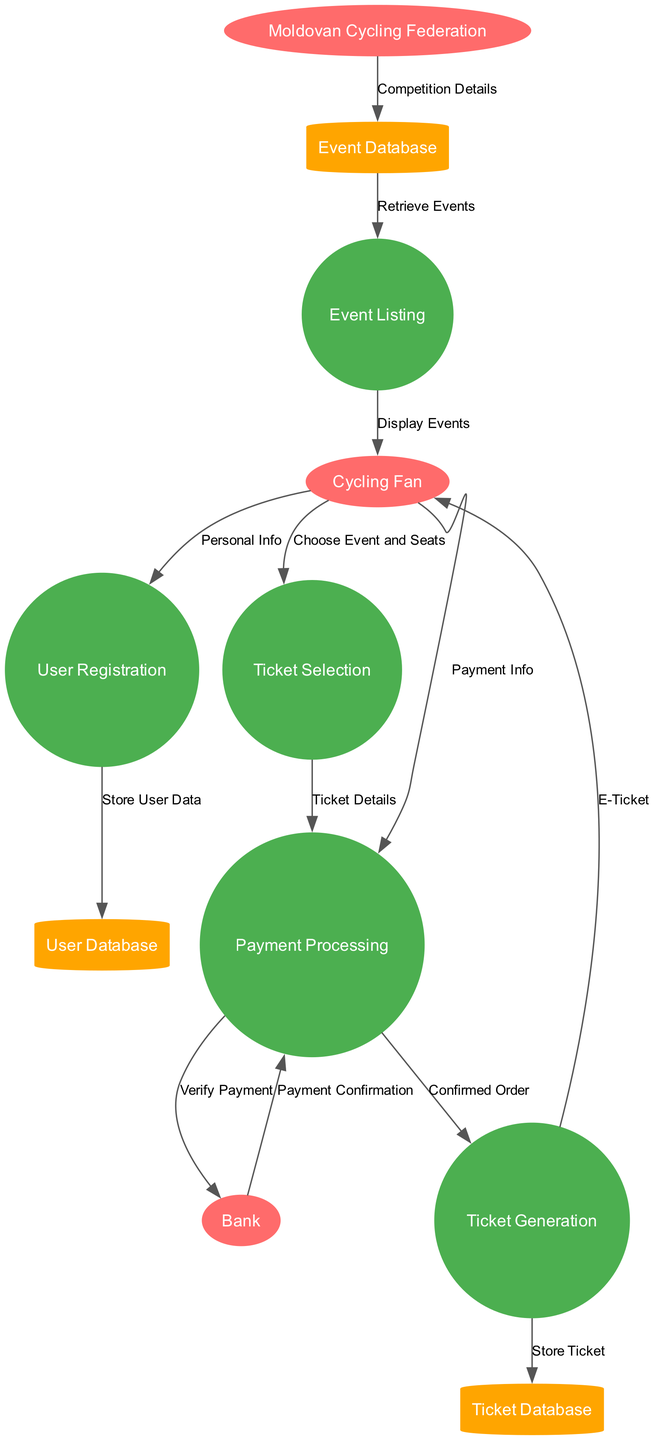What are the external entities in the diagram? The external entities listed are Cycling Fan, Bank, and Moldovan Cycling Federation. These entities represent outside participants that interact with the online ticket sales system.
Answer: Cycling Fan, Bank, Moldovan Cycling Federation How many processes are there in the diagram? The diagram contains five processes: User Registration, Event Listing, Ticket Selection, Payment Processing, and Ticket Generation. By counting these processes, we find the total number.
Answer: 5 Which process does the Ticket Selection connect to directly? The Ticket Selection process flows directly to the Payment Processing process. This is indicated by the data flow that shows how the selected ticket details are sent for further processing.
Answer: Payment Processing What information does the Cycling Fan send to the User Registration process? The Cycling Fan sends Personal Info to the User Registration process. This information is necessary for creating an account for the cycling fan in the system.
Answer: Personal Info What data store is updated when a new user registers? The User Database is updated when a new user registers. The data flow indicates that user data must be stored following the user registration process.
Answer: User Database Which entity is responsible for providing competition details? The Moldovan Cycling Federation is responsible for providing competition details, as shown by the data flow from this entity to the Event Database.
Answer: Moldovan Cycling Federation What is the final output for the Cycling Fan in the diagram? The final output for the Cycling Fan in the diagram is the E-Ticket. This is the end result of the ticketing process that is returned to the user after completing the purchase.
Answer: E-Ticket Where does the Ticket Generation process send ticket information after confirmation? The Ticket Generation process sends ticket information to the Ticket Database after confirming the order. This data flow indicates where the ticket information is stored for future reference.
Answer: Ticket Database What payment method does the Payment Processing use to verify payments? The Payment Processing uses a Bank to verify payments. This connection is made evident through the data flow indicating that payment details are forwarded to the bank for verification.
Answer: Bank 